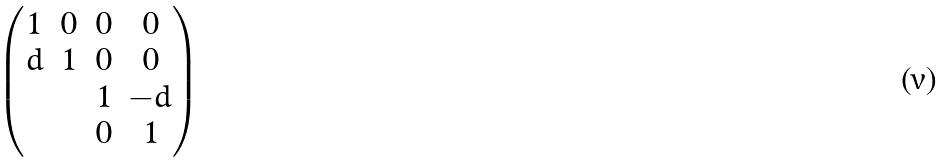<formula> <loc_0><loc_0><loc_500><loc_500>\begin{pmatrix} 1 & 0 & 0 & 0 \\ d & 1 & 0 & 0 \\ & & 1 & - d \\ & & 0 & 1 \end{pmatrix}</formula> 